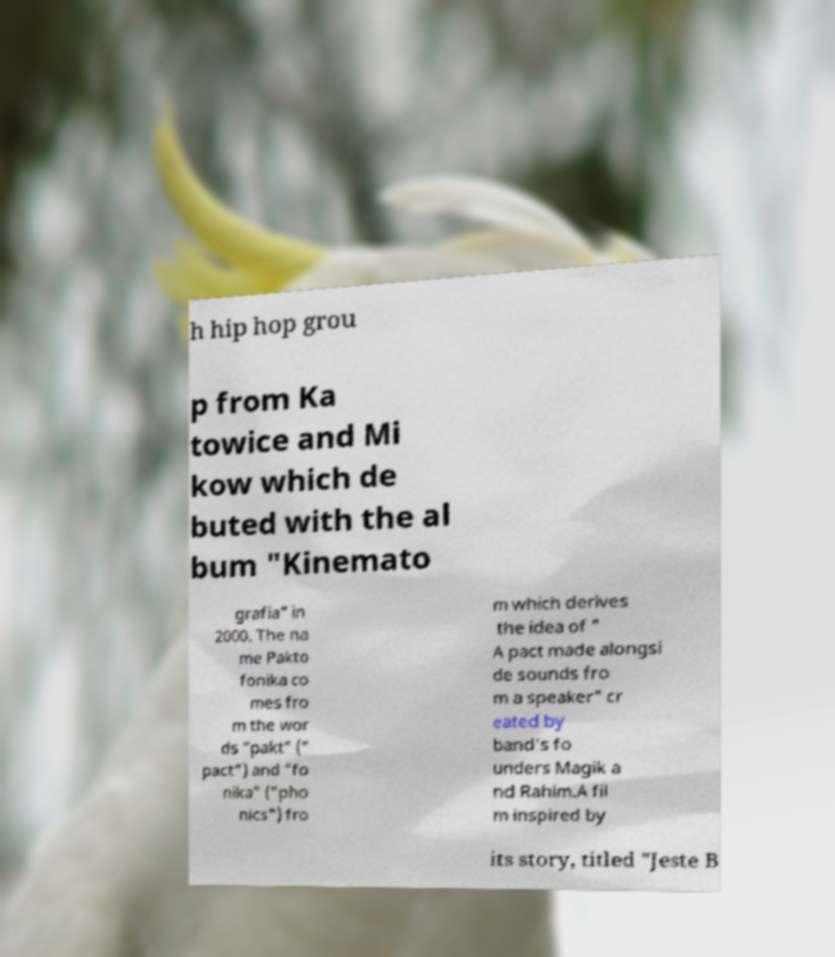What messages or text are displayed in this image? I need them in a readable, typed format. h hip hop grou p from Ka towice and Mi kow which de buted with the al bum "Kinemato grafia" in 2000. The na me Pakto fonika co mes fro m the wor ds "pakt" (" pact") and "fo nika" ("pho nics") fro m which derives the idea of " A pact made alongsi de sounds fro m a speaker" cr eated by band's fo unders Magik a nd Rahim.A fil m inspired by its story, titled "Jeste B 